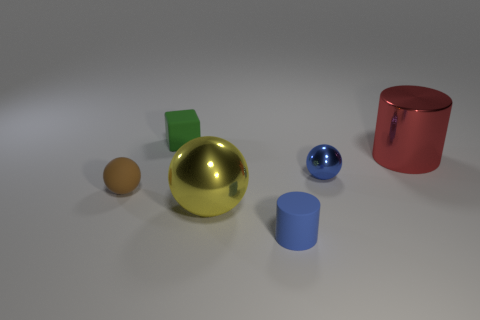Add 3 green cubes. How many objects exist? 9 Subtract all cylinders. How many objects are left? 4 Add 6 red things. How many red things are left? 7 Add 3 metal cubes. How many metal cubes exist? 3 Subtract 1 yellow spheres. How many objects are left? 5 Subtract all green rubber things. Subtract all green metallic things. How many objects are left? 5 